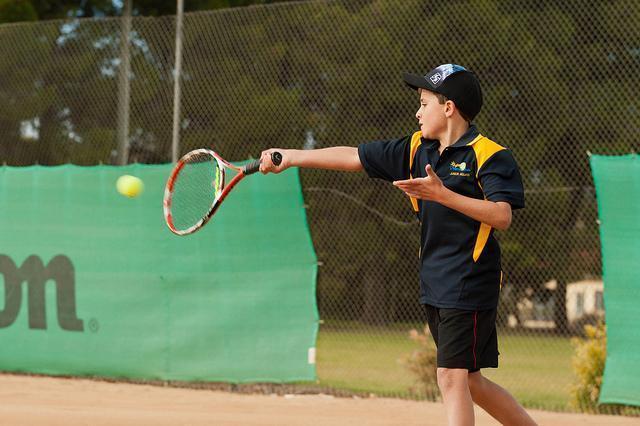Why are there letters on the green banners?
Choose the right answer from the provided options to respond to the question.
Options: Rules regulations, sign-ups, directions, company sponsorships. Company sponsorships. 